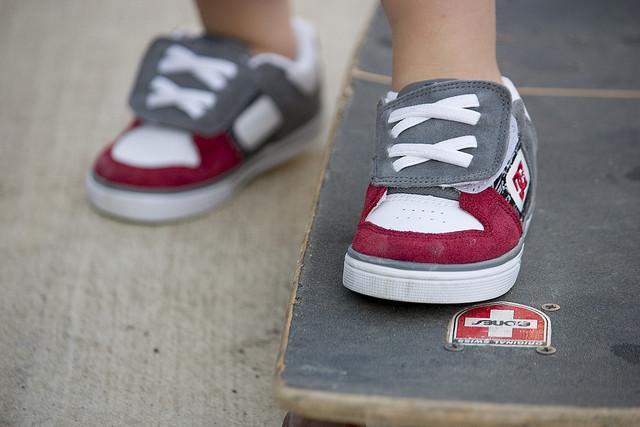How many feet are in focus?
Give a very brief answer. 1. How many people are there?
Give a very brief answer. 1. How many clocks are on the bottom half of the building?
Give a very brief answer. 0. 